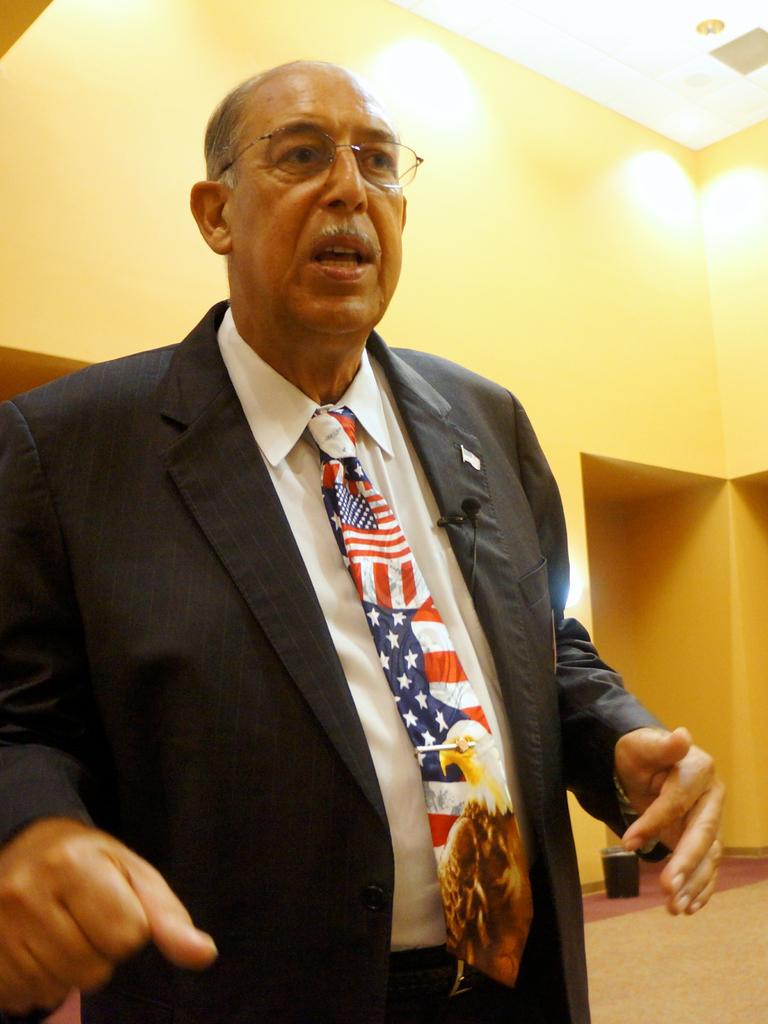Who or what is present in the image? There is a person in the image. What can be seen on the ground in the image? There is a black color object on the ground. What is the surface that the person and object are on? The ground is visible in the image. What structures are present in the image? There is a wall and a roof in the image. What can be seen illuminating the scene? There are lights in the image. Is the person walking on grass or quicksand in the image? The image does not show the person walking on grass or quicksand; it only shows the person standing on the ground. What scientific theory is being demonstrated in the image? There is no scientific theory being demonstrated in the image; it simply shows a person standing near a black object on the ground. 